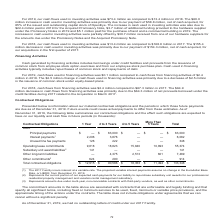According to Alarmcom Holdings's financial document, What does Subsidiary unit award liabilities represent? the current portion of our expected cash payments for our liability to repurchase subsidiary unit awards for our professional residential property management and vacation rental management subsidiary.. The document states: ", or LIBOR, from December 31, 2019. (2) Represents the current portion of our expected cash payments for our liability to repurchase subsidiary unit a..." Also, What does Other commitments represent? amounts due under multi-year, non-cancelable contracts with third-party vendors, as well as other commitments.. The document states: "ation rental management subsidiary. (3) Represents amounts due under multi-year, non-cancelable contracts with third-party vendors, as well as other c..." Also, What was the Total contractual obligations across all periods? According to the financial document, $133,348 (in thousands). The relevant text states: "obligations $ 12,915 $ 90,586 $ 18,353 $ 11,494 $ 133,348..." Also, can you calculate: What was the difference between total other long-term liabilities and total other commitments? Based on the calculation: 7,489-914, the result is 6575 (in thousands). This is based on the information: "141 Other long-term liabilities — 4,375 2,513 601 7,489 Other commitments 3 624 290 — — 914 Total contractual obligations $ 12,915 $ 90,586 $ 18,353 $ 11,4 5 2,513 601 7,489 Other commitments 3 624 29..." The key data points involved are: 7,489, 914. Also, can you calculate: What was the change in total contractual obligations between 1 Year and 2 to 3 Year periods? Based on the calculation: 90,586-12,915, the result is 77671 (in thousands). This is based on the information: "3 624 290 — — 914 Total contractual obligations $ 12,915 $ 90,586 $ 18,353 $ 11,494 $ 133,348 — — 914 Total contractual obligations $ 12,915 $ 90,586 $ 18,353 $ 11,494 $ 133,348..." The key data points involved are: 12,915, 90,586. Also, can you calculate: What was unused line fee payments as a percentage of total contractual obligations across all periods? Based on the calculation: 348/133,348, the result is 0.26 (percentage). This is based on the information: "obligations $ 12,915 $ 90,586 $ 18,353 $ 11,494 $ 133,348 obligations $ 12,915 $ 90,586 $ 18,353 $ 11,494 $ 133,348..." The key data points involved are: 133,348, 348. 